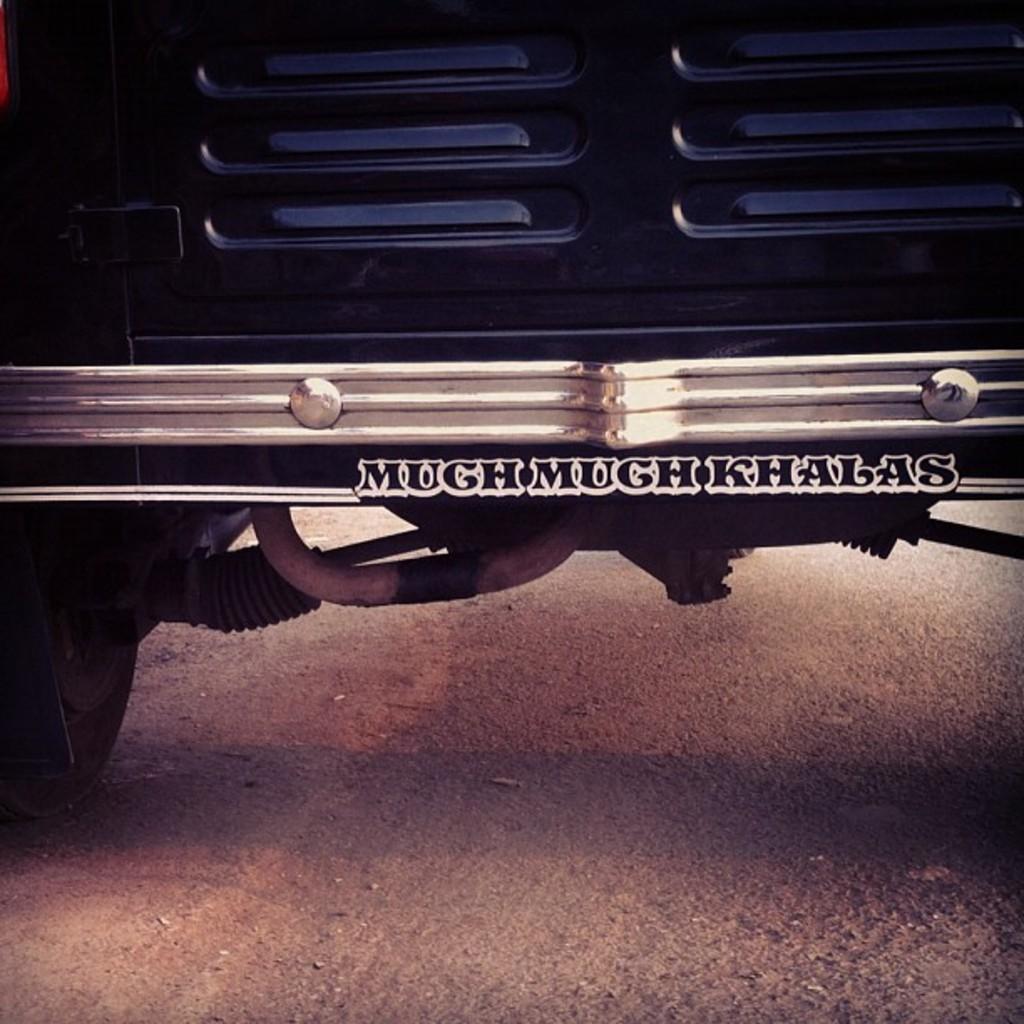Please provide a concise description of this image. In this picture there is an auto which is on the road. In the center I can see something is written. On the left there is a wheel. 